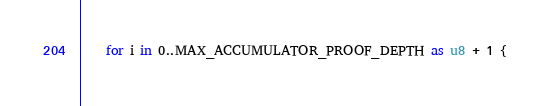<code> <loc_0><loc_0><loc_500><loc_500><_Rust_>    for i in 0..MAX_ACCUMULATOR_PROOF_DEPTH as u8 + 1 {</code> 